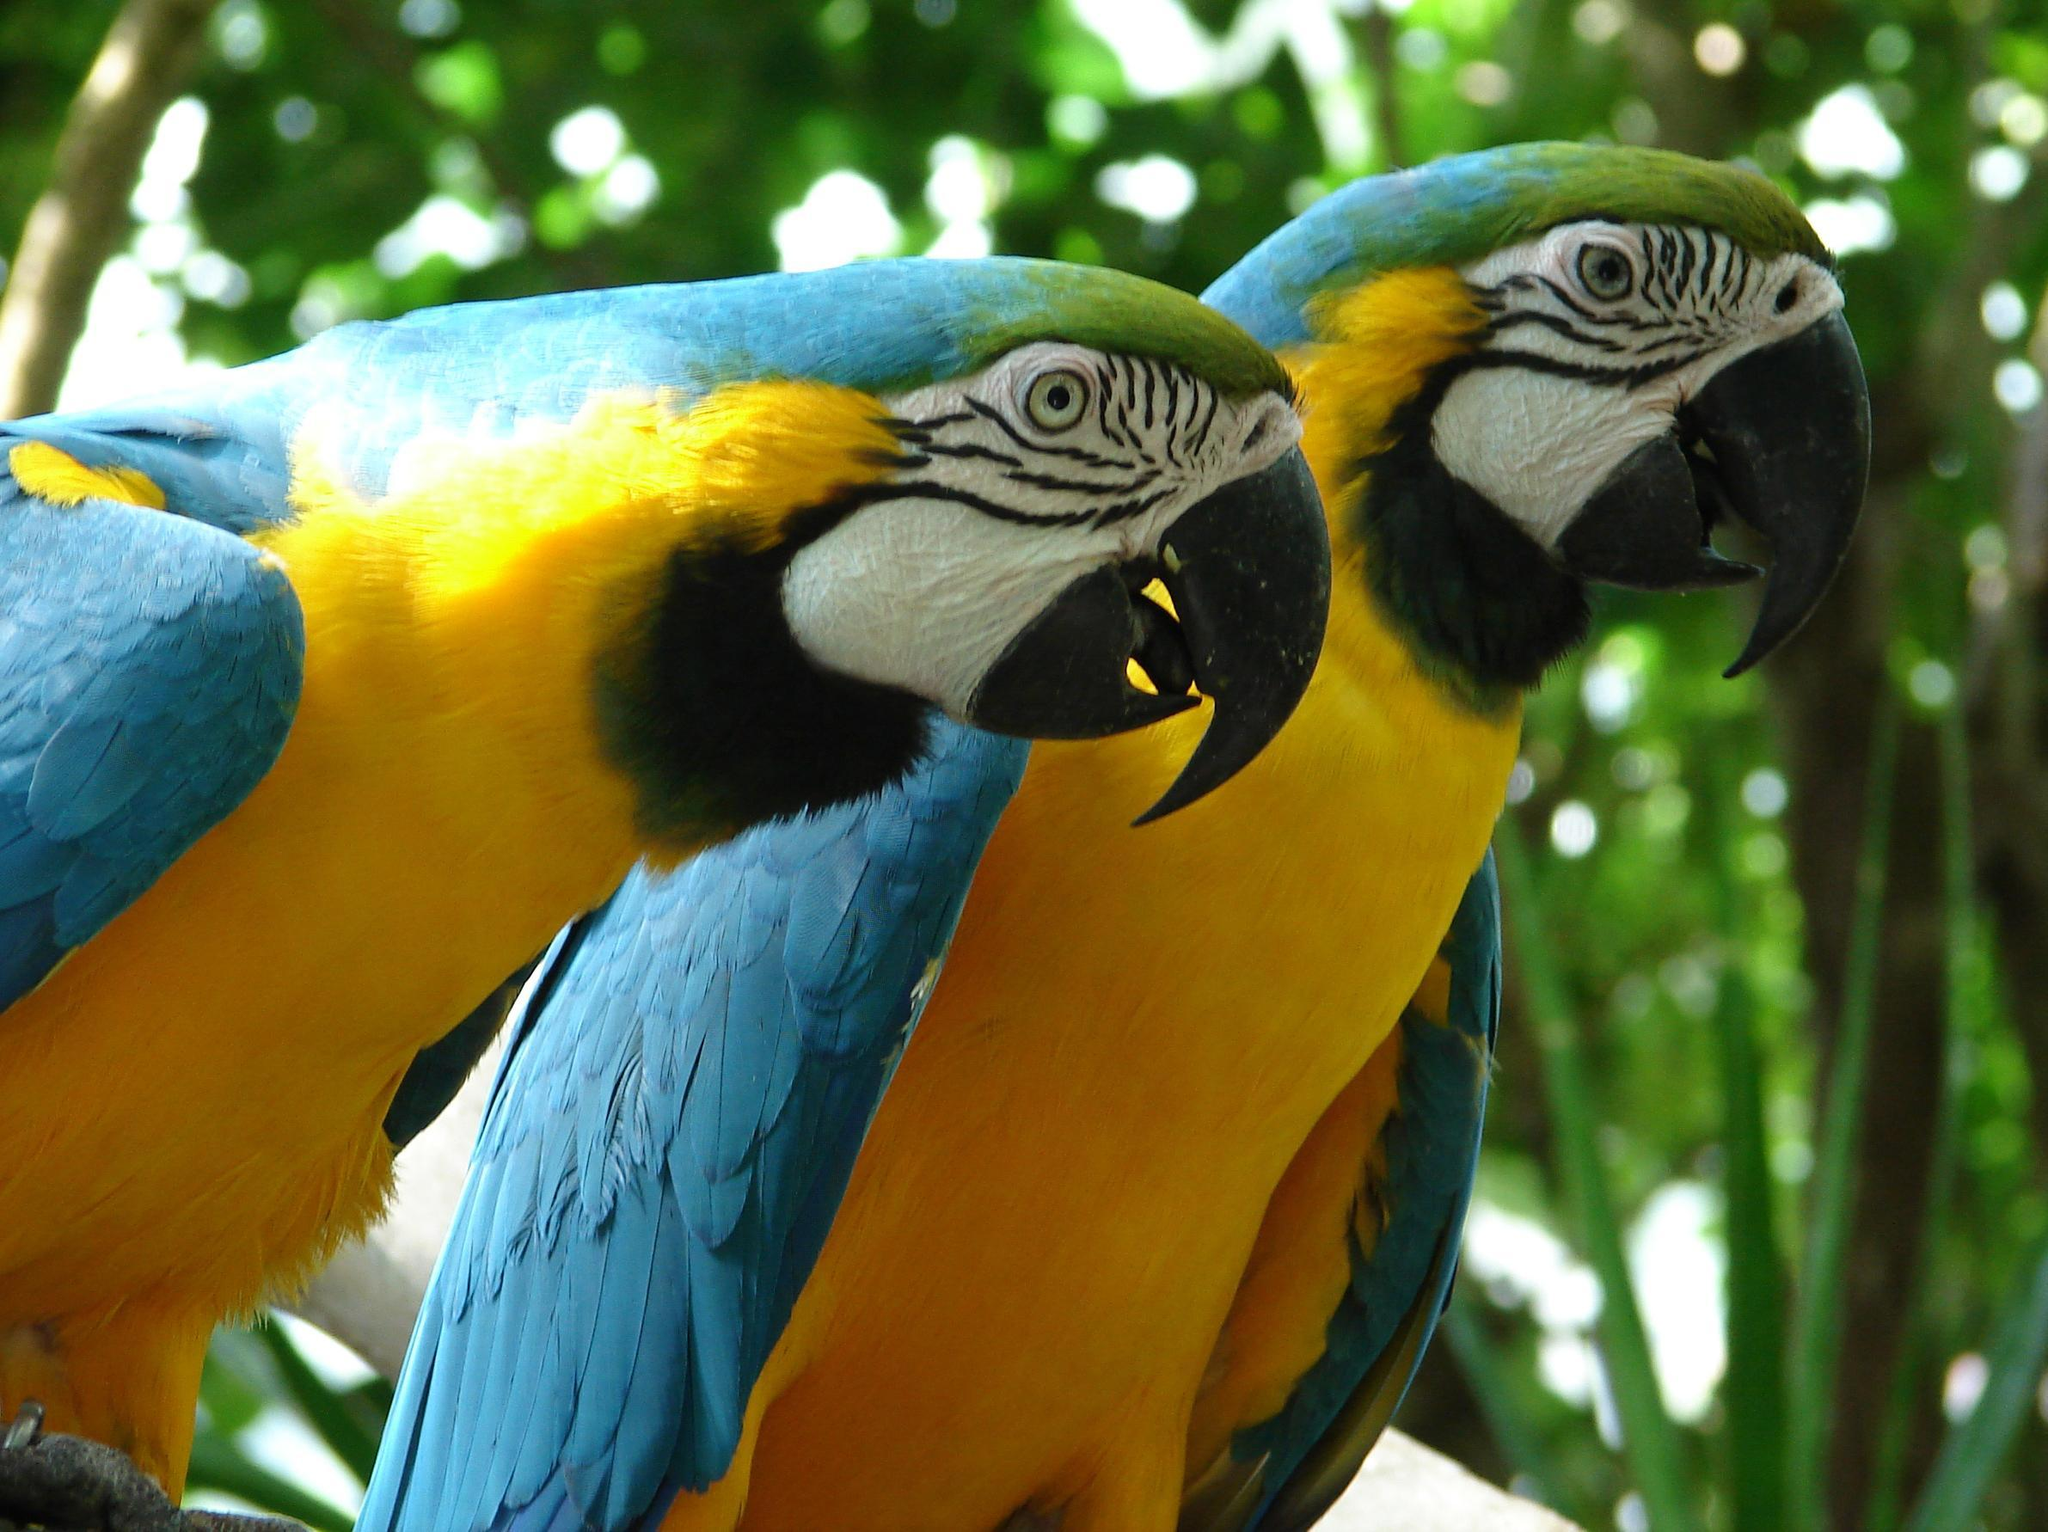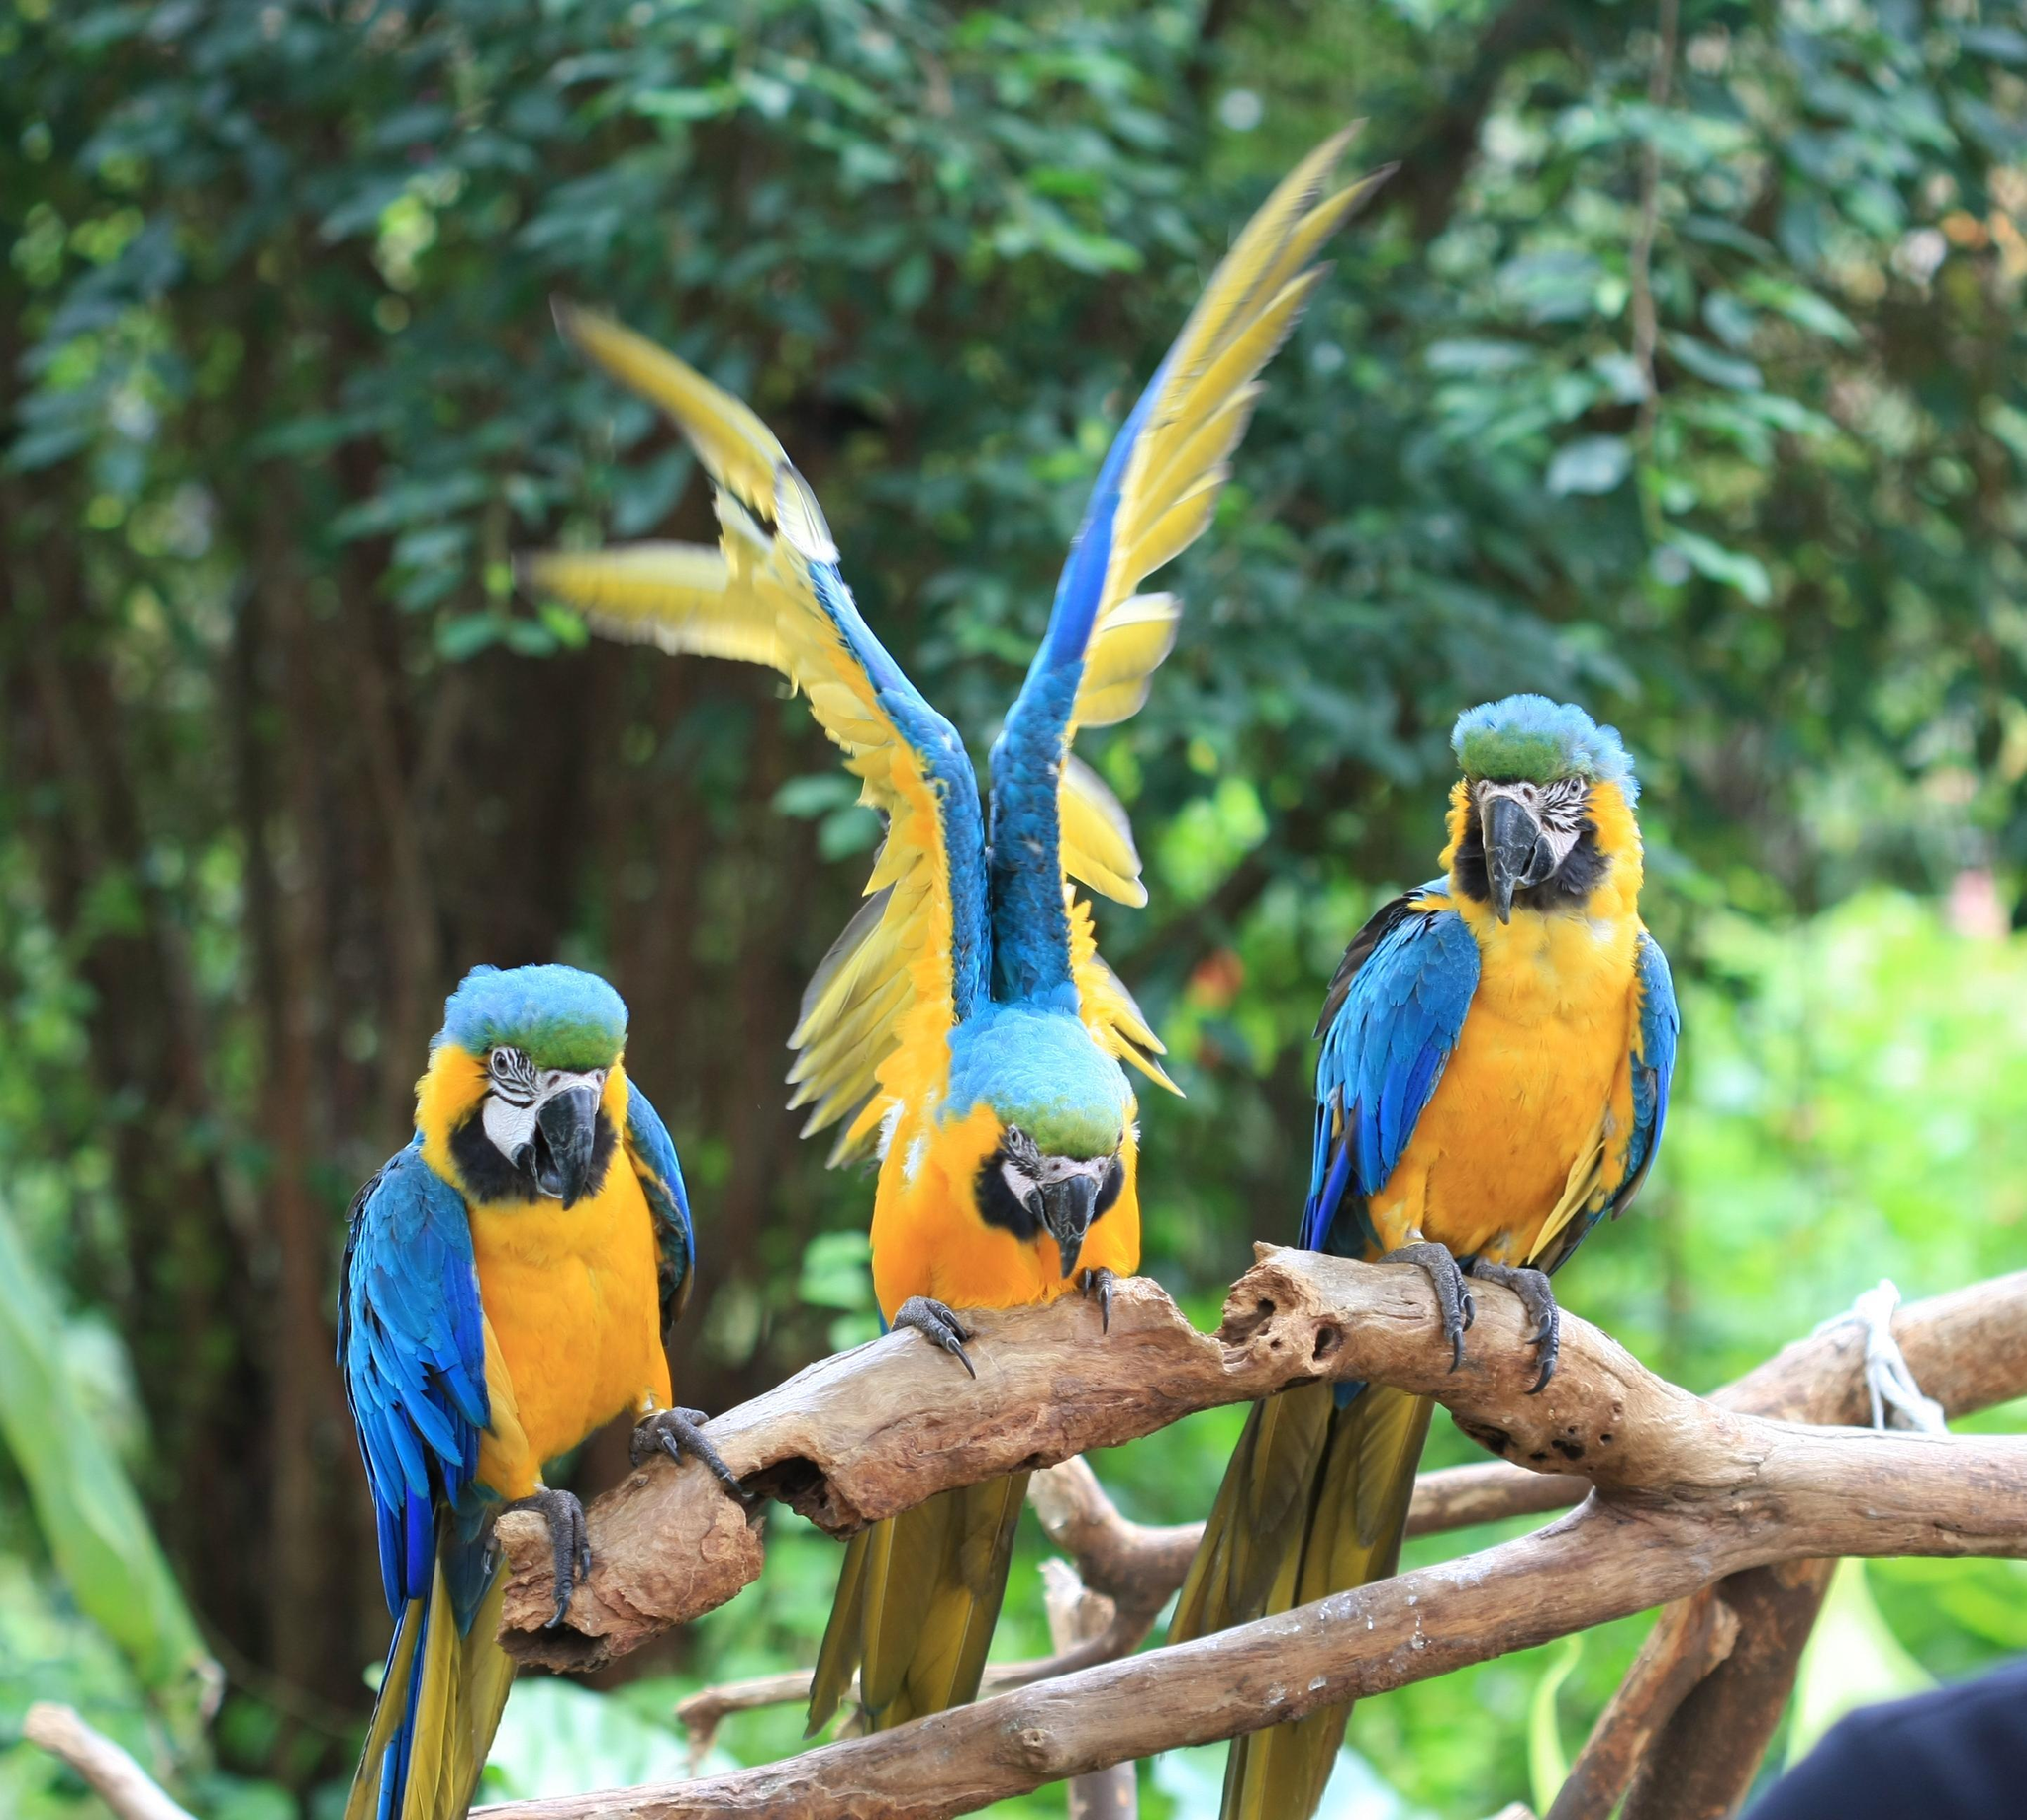The first image is the image on the left, the second image is the image on the right. Examine the images to the left and right. Is the description "One bird has its wings spread open." accurate? Answer yes or no. Yes. The first image is the image on the left, the second image is the image on the right. Examine the images to the left and right. Is the description "There are exactly three parrots in the right image standing on a branch." accurate? Answer yes or no. Yes. 